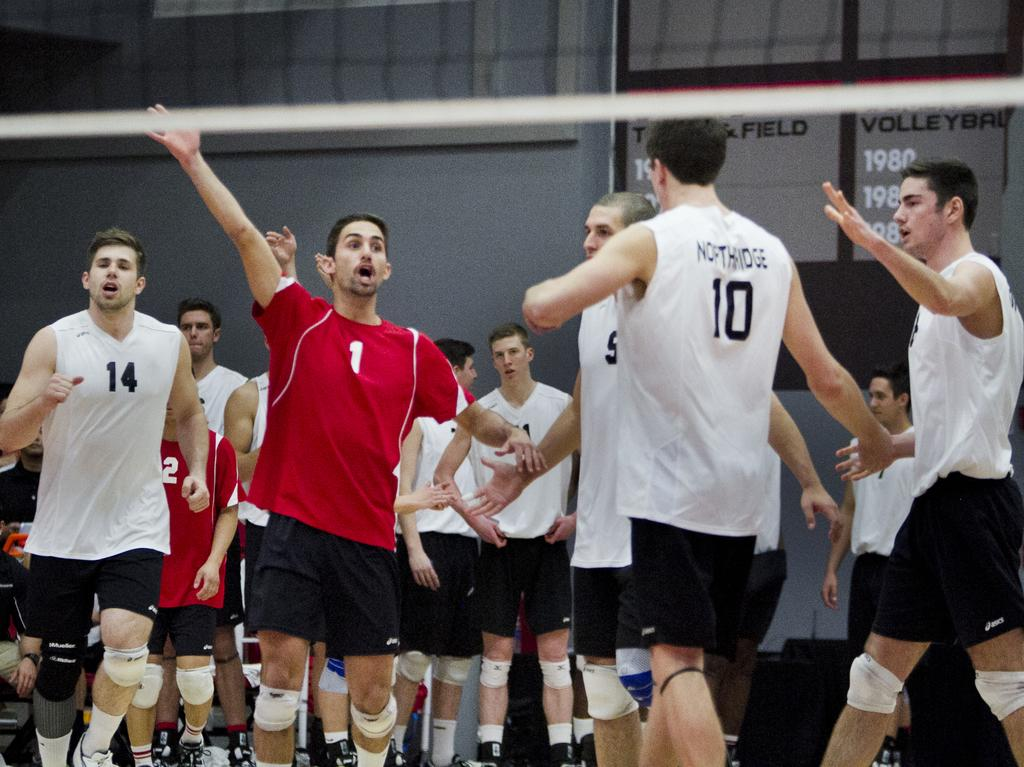How many people are in the image? There are many players in the image. What are the players doing in the image? The players are standing and talking to each other. What is the price of the brass stove in the image? There is no brass stove present in the image. 